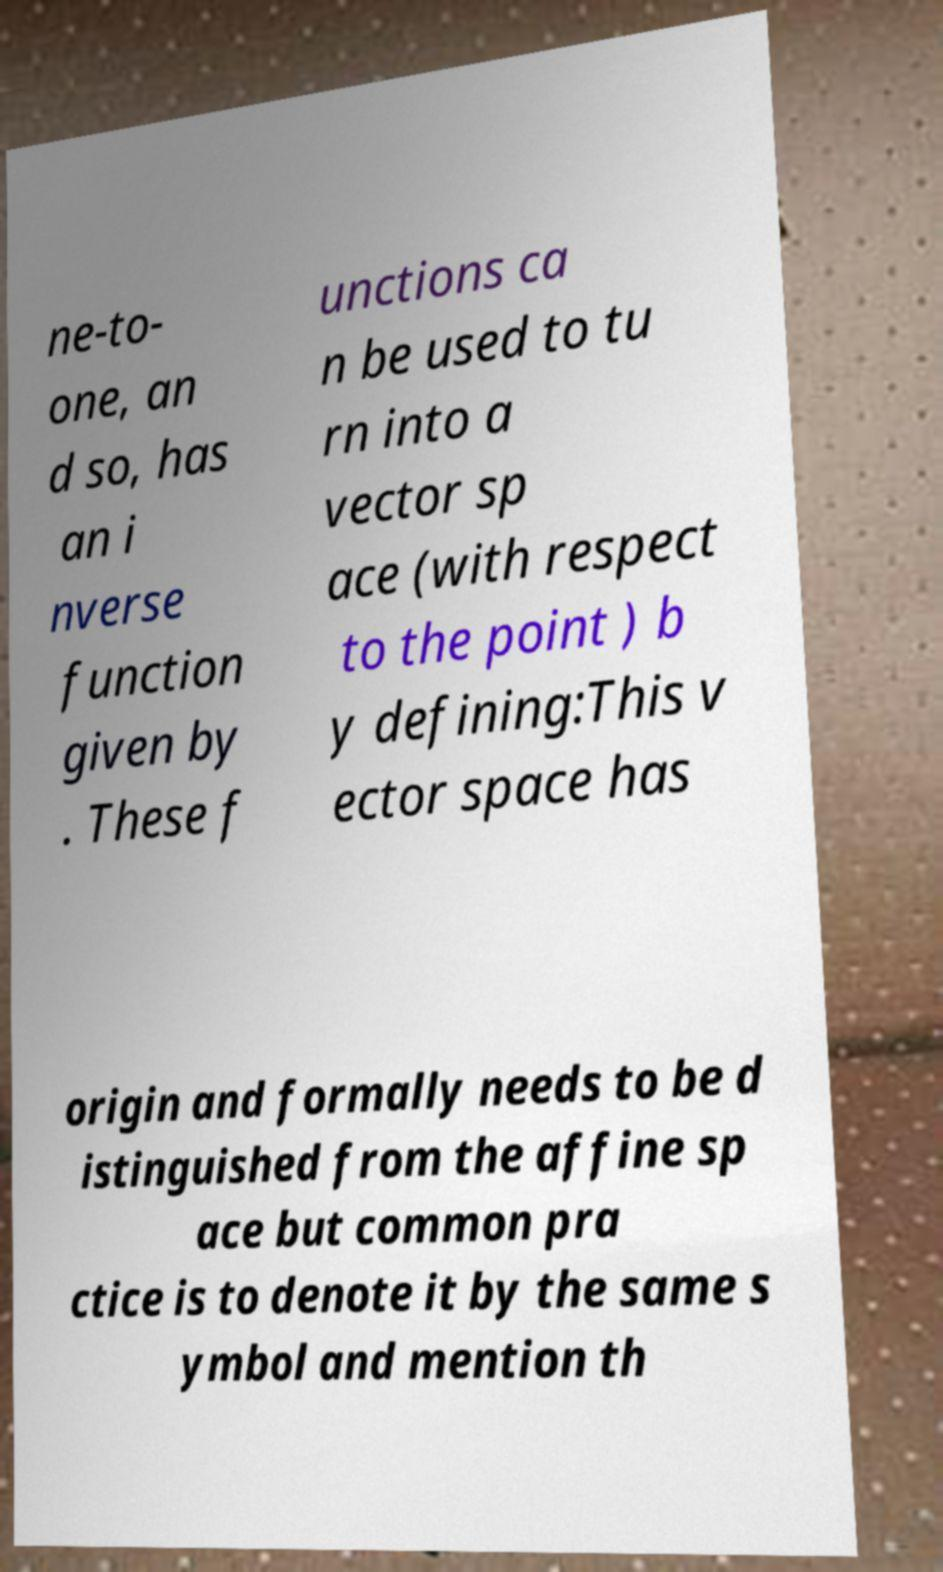Please read and relay the text visible in this image. What does it say? ne-to- one, an d so, has an i nverse function given by . These f unctions ca n be used to tu rn into a vector sp ace (with respect to the point ) b y defining:This v ector space has origin and formally needs to be d istinguished from the affine sp ace but common pra ctice is to denote it by the same s ymbol and mention th 